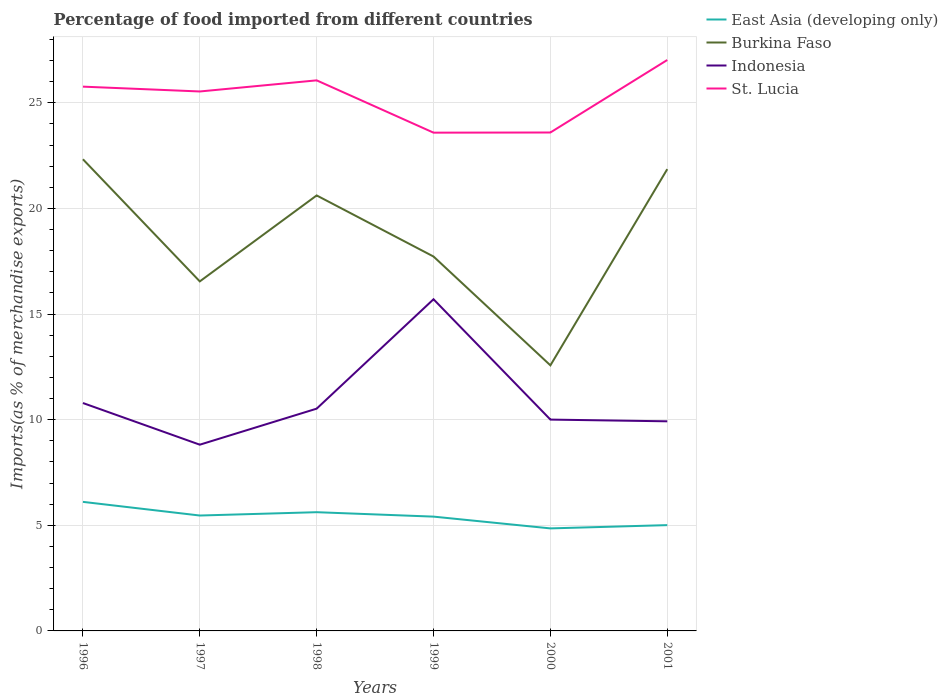Is the number of lines equal to the number of legend labels?
Offer a very short reply. Yes. Across all years, what is the maximum percentage of imports to different countries in Indonesia?
Your answer should be very brief. 8.82. What is the total percentage of imports to different countries in Indonesia in the graph?
Your response must be concise. -6.88. What is the difference between the highest and the second highest percentage of imports to different countries in St. Lucia?
Your answer should be compact. 3.44. What is the difference between the highest and the lowest percentage of imports to different countries in St. Lucia?
Ensure brevity in your answer.  4. How many lines are there?
Keep it short and to the point. 4. How many years are there in the graph?
Make the answer very short. 6. Does the graph contain any zero values?
Your answer should be compact. No. Does the graph contain grids?
Offer a very short reply. Yes. Where does the legend appear in the graph?
Give a very brief answer. Top right. How are the legend labels stacked?
Offer a very short reply. Vertical. What is the title of the graph?
Ensure brevity in your answer.  Percentage of food imported from different countries. What is the label or title of the X-axis?
Your response must be concise. Years. What is the label or title of the Y-axis?
Provide a succinct answer. Imports(as % of merchandise exports). What is the Imports(as % of merchandise exports) of East Asia (developing only) in 1996?
Offer a very short reply. 6.11. What is the Imports(as % of merchandise exports) in Burkina Faso in 1996?
Provide a short and direct response. 22.33. What is the Imports(as % of merchandise exports) of Indonesia in 1996?
Your response must be concise. 10.79. What is the Imports(as % of merchandise exports) of St. Lucia in 1996?
Ensure brevity in your answer.  25.77. What is the Imports(as % of merchandise exports) in East Asia (developing only) in 1997?
Give a very brief answer. 5.46. What is the Imports(as % of merchandise exports) of Burkina Faso in 1997?
Give a very brief answer. 16.55. What is the Imports(as % of merchandise exports) in Indonesia in 1997?
Make the answer very short. 8.82. What is the Imports(as % of merchandise exports) in St. Lucia in 1997?
Offer a very short reply. 25.54. What is the Imports(as % of merchandise exports) in East Asia (developing only) in 1998?
Make the answer very short. 5.62. What is the Imports(as % of merchandise exports) in Burkina Faso in 1998?
Give a very brief answer. 20.62. What is the Imports(as % of merchandise exports) in Indonesia in 1998?
Ensure brevity in your answer.  10.52. What is the Imports(as % of merchandise exports) of St. Lucia in 1998?
Provide a short and direct response. 26.06. What is the Imports(as % of merchandise exports) of East Asia (developing only) in 1999?
Offer a terse response. 5.41. What is the Imports(as % of merchandise exports) of Burkina Faso in 1999?
Offer a terse response. 17.72. What is the Imports(as % of merchandise exports) in Indonesia in 1999?
Ensure brevity in your answer.  15.7. What is the Imports(as % of merchandise exports) of St. Lucia in 1999?
Your response must be concise. 23.59. What is the Imports(as % of merchandise exports) in East Asia (developing only) in 2000?
Offer a terse response. 4.85. What is the Imports(as % of merchandise exports) of Burkina Faso in 2000?
Your response must be concise. 12.57. What is the Imports(as % of merchandise exports) in Indonesia in 2000?
Keep it short and to the point. 10. What is the Imports(as % of merchandise exports) in St. Lucia in 2000?
Your response must be concise. 23.6. What is the Imports(as % of merchandise exports) in East Asia (developing only) in 2001?
Make the answer very short. 5.01. What is the Imports(as % of merchandise exports) in Burkina Faso in 2001?
Your response must be concise. 21.86. What is the Imports(as % of merchandise exports) of Indonesia in 2001?
Offer a terse response. 9.92. What is the Imports(as % of merchandise exports) of St. Lucia in 2001?
Your response must be concise. 27.03. Across all years, what is the maximum Imports(as % of merchandise exports) in East Asia (developing only)?
Keep it short and to the point. 6.11. Across all years, what is the maximum Imports(as % of merchandise exports) in Burkina Faso?
Keep it short and to the point. 22.33. Across all years, what is the maximum Imports(as % of merchandise exports) of Indonesia?
Provide a short and direct response. 15.7. Across all years, what is the maximum Imports(as % of merchandise exports) in St. Lucia?
Ensure brevity in your answer.  27.03. Across all years, what is the minimum Imports(as % of merchandise exports) of East Asia (developing only)?
Offer a very short reply. 4.85. Across all years, what is the minimum Imports(as % of merchandise exports) in Burkina Faso?
Offer a terse response. 12.57. Across all years, what is the minimum Imports(as % of merchandise exports) in Indonesia?
Provide a short and direct response. 8.82. Across all years, what is the minimum Imports(as % of merchandise exports) of St. Lucia?
Make the answer very short. 23.59. What is the total Imports(as % of merchandise exports) of East Asia (developing only) in the graph?
Offer a very short reply. 32.47. What is the total Imports(as % of merchandise exports) of Burkina Faso in the graph?
Make the answer very short. 111.65. What is the total Imports(as % of merchandise exports) of Indonesia in the graph?
Your answer should be compact. 65.76. What is the total Imports(as % of merchandise exports) in St. Lucia in the graph?
Offer a terse response. 151.58. What is the difference between the Imports(as % of merchandise exports) in East Asia (developing only) in 1996 and that in 1997?
Your response must be concise. 0.65. What is the difference between the Imports(as % of merchandise exports) of Burkina Faso in 1996 and that in 1997?
Ensure brevity in your answer.  5.78. What is the difference between the Imports(as % of merchandise exports) in Indonesia in 1996 and that in 1997?
Ensure brevity in your answer.  1.97. What is the difference between the Imports(as % of merchandise exports) of St. Lucia in 1996 and that in 1997?
Make the answer very short. 0.23. What is the difference between the Imports(as % of merchandise exports) in East Asia (developing only) in 1996 and that in 1998?
Your response must be concise. 0.49. What is the difference between the Imports(as % of merchandise exports) of Burkina Faso in 1996 and that in 1998?
Your answer should be compact. 1.71. What is the difference between the Imports(as % of merchandise exports) in Indonesia in 1996 and that in 1998?
Provide a short and direct response. 0.27. What is the difference between the Imports(as % of merchandise exports) in St. Lucia in 1996 and that in 1998?
Keep it short and to the point. -0.3. What is the difference between the Imports(as % of merchandise exports) of East Asia (developing only) in 1996 and that in 1999?
Offer a very short reply. 0.7. What is the difference between the Imports(as % of merchandise exports) in Burkina Faso in 1996 and that in 1999?
Ensure brevity in your answer.  4.6. What is the difference between the Imports(as % of merchandise exports) of Indonesia in 1996 and that in 1999?
Make the answer very short. -4.91. What is the difference between the Imports(as % of merchandise exports) of St. Lucia in 1996 and that in 1999?
Your answer should be compact. 2.18. What is the difference between the Imports(as % of merchandise exports) of East Asia (developing only) in 1996 and that in 2000?
Provide a short and direct response. 1.26. What is the difference between the Imports(as % of merchandise exports) of Burkina Faso in 1996 and that in 2000?
Provide a short and direct response. 9.76. What is the difference between the Imports(as % of merchandise exports) of Indonesia in 1996 and that in 2000?
Give a very brief answer. 0.78. What is the difference between the Imports(as % of merchandise exports) of St. Lucia in 1996 and that in 2000?
Offer a very short reply. 2.17. What is the difference between the Imports(as % of merchandise exports) in East Asia (developing only) in 1996 and that in 2001?
Provide a succinct answer. 1.1. What is the difference between the Imports(as % of merchandise exports) of Burkina Faso in 1996 and that in 2001?
Provide a succinct answer. 0.47. What is the difference between the Imports(as % of merchandise exports) of Indonesia in 1996 and that in 2001?
Provide a short and direct response. 0.87. What is the difference between the Imports(as % of merchandise exports) in St. Lucia in 1996 and that in 2001?
Offer a terse response. -1.26. What is the difference between the Imports(as % of merchandise exports) of East Asia (developing only) in 1997 and that in 1998?
Offer a terse response. -0.16. What is the difference between the Imports(as % of merchandise exports) of Burkina Faso in 1997 and that in 1998?
Your response must be concise. -4.07. What is the difference between the Imports(as % of merchandise exports) of Indonesia in 1997 and that in 1998?
Offer a terse response. -1.71. What is the difference between the Imports(as % of merchandise exports) of St. Lucia in 1997 and that in 1998?
Your answer should be very brief. -0.53. What is the difference between the Imports(as % of merchandise exports) of East Asia (developing only) in 1997 and that in 1999?
Provide a short and direct response. 0.05. What is the difference between the Imports(as % of merchandise exports) in Burkina Faso in 1997 and that in 1999?
Offer a very short reply. -1.18. What is the difference between the Imports(as % of merchandise exports) in Indonesia in 1997 and that in 1999?
Offer a very short reply. -6.88. What is the difference between the Imports(as % of merchandise exports) in St. Lucia in 1997 and that in 1999?
Your answer should be compact. 1.95. What is the difference between the Imports(as % of merchandise exports) in East Asia (developing only) in 1997 and that in 2000?
Provide a short and direct response. 0.61. What is the difference between the Imports(as % of merchandise exports) in Burkina Faso in 1997 and that in 2000?
Give a very brief answer. 3.97. What is the difference between the Imports(as % of merchandise exports) of Indonesia in 1997 and that in 2000?
Make the answer very short. -1.19. What is the difference between the Imports(as % of merchandise exports) in St. Lucia in 1997 and that in 2000?
Your response must be concise. 1.94. What is the difference between the Imports(as % of merchandise exports) in East Asia (developing only) in 1997 and that in 2001?
Your response must be concise. 0.45. What is the difference between the Imports(as % of merchandise exports) of Burkina Faso in 1997 and that in 2001?
Provide a succinct answer. -5.31. What is the difference between the Imports(as % of merchandise exports) in Indonesia in 1997 and that in 2001?
Give a very brief answer. -1.11. What is the difference between the Imports(as % of merchandise exports) of St. Lucia in 1997 and that in 2001?
Keep it short and to the point. -1.49. What is the difference between the Imports(as % of merchandise exports) of East Asia (developing only) in 1998 and that in 1999?
Provide a succinct answer. 0.21. What is the difference between the Imports(as % of merchandise exports) in Burkina Faso in 1998 and that in 1999?
Make the answer very short. 2.89. What is the difference between the Imports(as % of merchandise exports) of Indonesia in 1998 and that in 1999?
Your answer should be compact. -5.18. What is the difference between the Imports(as % of merchandise exports) of St. Lucia in 1998 and that in 1999?
Your answer should be very brief. 2.48. What is the difference between the Imports(as % of merchandise exports) of East Asia (developing only) in 1998 and that in 2000?
Provide a succinct answer. 0.77. What is the difference between the Imports(as % of merchandise exports) in Burkina Faso in 1998 and that in 2000?
Your answer should be very brief. 8.04. What is the difference between the Imports(as % of merchandise exports) of Indonesia in 1998 and that in 2000?
Offer a terse response. 0.52. What is the difference between the Imports(as % of merchandise exports) of St. Lucia in 1998 and that in 2000?
Keep it short and to the point. 2.47. What is the difference between the Imports(as % of merchandise exports) in East Asia (developing only) in 1998 and that in 2001?
Provide a short and direct response. 0.61. What is the difference between the Imports(as % of merchandise exports) in Burkina Faso in 1998 and that in 2001?
Provide a short and direct response. -1.25. What is the difference between the Imports(as % of merchandise exports) of Indonesia in 1998 and that in 2001?
Offer a terse response. 0.6. What is the difference between the Imports(as % of merchandise exports) in St. Lucia in 1998 and that in 2001?
Provide a succinct answer. -0.96. What is the difference between the Imports(as % of merchandise exports) of East Asia (developing only) in 1999 and that in 2000?
Your answer should be compact. 0.56. What is the difference between the Imports(as % of merchandise exports) in Burkina Faso in 1999 and that in 2000?
Keep it short and to the point. 5.15. What is the difference between the Imports(as % of merchandise exports) in Indonesia in 1999 and that in 2000?
Provide a short and direct response. 5.7. What is the difference between the Imports(as % of merchandise exports) in St. Lucia in 1999 and that in 2000?
Provide a succinct answer. -0.01. What is the difference between the Imports(as % of merchandise exports) of East Asia (developing only) in 1999 and that in 2001?
Offer a very short reply. 0.4. What is the difference between the Imports(as % of merchandise exports) in Burkina Faso in 1999 and that in 2001?
Make the answer very short. -4.14. What is the difference between the Imports(as % of merchandise exports) of Indonesia in 1999 and that in 2001?
Keep it short and to the point. 5.78. What is the difference between the Imports(as % of merchandise exports) in St. Lucia in 1999 and that in 2001?
Offer a terse response. -3.44. What is the difference between the Imports(as % of merchandise exports) of East Asia (developing only) in 2000 and that in 2001?
Provide a succinct answer. -0.15. What is the difference between the Imports(as % of merchandise exports) of Burkina Faso in 2000 and that in 2001?
Your response must be concise. -9.29. What is the difference between the Imports(as % of merchandise exports) in Indonesia in 2000 and that in 2001?
Your response must be concise. 0.08. What is the difference between the Imports(as % of merchandise exports) of St. Lucia in 2000 and that in 2001?
Your answer should be very brief. -3.43. What is the difference between the Imports(as % of merchandise exports) of East Asia (developing only) in 1996 and the Imports(as % of merchandise exports) of Burkina Faso in 1997?
Provide a short and direct response. -10.44. What is the difference between the Imports(as % of merchandise exports) of East Asia (developing only) in 1996 and the Imports(as % of merchandise exports) of Indonesia in 1997?
Provide a succinct answer. -2.71. What is the difference between the Imports(as % of merchandise exports) in East Asia (developing only) in 1996 and the Imports(as % of merchandise exports) in St. Lucia in 1997?
Provide a succinct answer. -19.43. What is the difference between the Imports(as % of merchandise exports) in Burkina Faso in 1996 and the Imports(as % of merchandise exports) in Indonesia in 1997?
Give a very brief answer. 13.51. What is the difference between the Imports(as % of merchandise exports) in Burkina Faso in 1996 and the Imports(as % of merchandise exports) in St. Lucia in 1997?
Offer a very short reply. -3.21. What is the difference between the Imports(as % of merchandise exports) in Indonesia in 1996 and the Imports(as % of merchandise exports) in St. Lucia in 1997?
Your answer should be very brief. -14.75. What is the difference between the Imports(as % of merchandise exports) of East Asia (developing only) in 1996 and the Imports(as % of merchandise exports) of Burkina Faso in 1998?
Your response must be concise. -14.51. What is the difference between the Imports(as % of merchandise exports) in East Asia (developing only) in 1996 and the Imports(as % of merchandise exports) in Indonesia in 1998?
Your answer should be very brief. -4.41. What is the difference between the Imports(as % of merchandise exports) of East Asia (developing only) in 1996 and the Imports(as % of merchandise exports) of St. Lucia in 1998?
Keep it short and to the point. -19.95. What is the difference between the Imports(as % of merchandise exports) in Burkina Faso in 1996 and the Imports(as % of merchandise exports) in Indonesia in 1998?
Your response must be concise. 11.81. What is the difference between the Imports(as % of merchandise exports) of Burkina Faso in 1996 and the Imports(as % of merchandise exports) of St. Lucia in 1998?
Give a very brief answer. -3.74. What is the difference between the Imports(as % of merchandise exports) in Indonesia in 1996 and the Imports(as % of merchandise exports) in St. Lucia in 1998?
Ensure brevity in your answer.  -15.28. What is the difference between the Imports(as % of merchandise exports) of East Asia (developing only) in 1996 and the Imports(as % of merchandise exports) of Burkina Faso in 1999?
Make the answer very short. -11.61. What is the difference between the Imports(as % of merchandise exports) in East Asia (developing only) in 1996 and the Imports(as % of merchandise exports) in Indonesia in 1999?
Offer a terse response. -9.59. What is the difference between the Imports(as % of merchandise exports) of East Asia (developing only) in 1996 and the Imports(as % of merchandise exports) of St. Lucia in 1999?
Your answer should be compact. -17.48. What is the difference between the Imports(as % of merchandise exports) in Burkina Faso in 1996 and the Imports(as % of merchandise exports) in Indonesia in 1999?
Your response must be concise. 6.63. What is the difference between the Imports(as % of merchandise exports) of Burkina Faso in 1996 and the Imports(as % of merchandise exports) of St. Lucia in 1999?
Your response must be concise. -1.26. What is the difference between the Imports(as % of merchandise exports) of Indonesia in 1996 and the Imports(as % of merchandise exports) of St. Lucia in 1999?
Make the answer very short. -12.8. What is the difference between the Imports(as % of merchandise exports) in East Asia (developing only) in 1996 and the Imports(as % of merchandise exports) in Burkina Faso in 2000?
Offer a terse response. -6.46. What is the difference between the Imports(as % of merchandise exports) of East Asia (developing only) in 1996 and the Imports(as % of merchandise exports) of Indonesia in 2000?
Offer a terse response. -3.9. What is the difference between the Imports(as % of merchandise exports) of East Asia (developing only) in 1996 and the Imports(as % of merchandise exports) of St. Lucia in 2000?
Your answer should be compact. -17.49. What is the difference between the Imports(as % of merchandise exports) of Burkina Faso in 1996 and the Imports(as % of merchandise exports) of Indonesia in 2000?
Provide a short and direct response. 12.32. What is the difference between the Imports(as % of merchandise exports) of Burkina Faso in 1996 and the Imports(as % of merchandise exports) of St. Lucia in 2000?
Offer a terse response. -1.27. What is the difference between the Imports(as % of merchandise exports) in Indonesia in 1996 and the Imports(as % of merchandise exports) in St. Lucia in 2000?
Ensure brevity in your answer.  -12.81. What is the difference between the Imports(as % of merchandise exports) in East Asia (developing only) in 1996 and the Imports(as % of merchandise exports) in Burkina Faso in 2001?
Provide a succinct answer. -15.75. What is the difference between the Imports(as % of merchandise exports) in East Asia (developing only) in 1996 and the Imports(as % of merchandise exports) in Indonesia in 2001?
Provide a succinct answer. -3.81. What is the difference between the Imports(as % of merchandise exports) in East Asia (developing only) in 1996 and the Imports(as % of merchandise exports) in St. Lucia in 2001?
Keep it short and to the point. -20.92. What is the difference between the Imports(as % of merchandise exports) of Burkina Faso in 1996 and the Imports(as % of merchandise exports) of Indonesia in 2001?
Your answer should be compact. 12.41. What is the difference between the Imports(as % of merchandise exports) of Burkina Faso in 1996 and the Imports(as % of merchandise exports) of St. Lucia in 2001?
Your response must be concise. -4.7. What is the difference between the Imports(as % of merchandise exports) in Indonesia in 1996 and the Imports(as % of merchandise exports) in St. Lucia in 2001?
Ensure brevity in your answer.  -16.24. What is the difference between the Imports(as % of merchandise exports) of East Asia (developing only) in 1997 and the Imports(as % of merchandise exports) of Burkina Faso in 1998?
Your answer should be compact. -15.15. What is the difference between the Imports(as % of merchandise exports) of East Asia (developing only) in 1997 and the Imports(as % of merchandise exports) of Indonesia in 1998?
Your answer should be compact. -5.06. What is the difference between the Imports(as % of merchandise exports) in East Asia (developing only) in 1997 and the Imports(as % of merchandise exports) in St. Lucia in 1998?
Keep it short and to the point. -20.6. What is the difference between the Imports(as % of merchandise exports) in Burkina Faso in 1997 and the Imports(as % of merchandise exports) in Indonesia in 1998?
Provide a short and direct response. 6.02. What is the difference between the Imports(as % of merchandise exports) in Burkina Faso in 1997 and the Imports(as % of merchandise exports) in St. Lucia in 1998?
Offer a very short reply. -9.52. What is the difference between the Imports(as % of merchandise exports) of Indonesia in 1997 and the Imports(as % of merchandise exports) of St. Lucia in 1998?
Your answer should be very brief. -17.25. What is the difference between the Imports(as % of merchandise exports) of East Asia (developing only) in 1997 and the Imports(as % of merchandise exports) of Burkina Faso in 1999?
Ensure brevity in your answer.  -12.26. What is the difference between the Imports(as % of merchandise exports) of East Asia (developing only) in 1997 and the Imports(as % of merchandise exports) of Indonesia in 1999?
Offer a very short reply. -10.24. What is the difference between the Imports(as % of merchandise exports) of East Asia (developing only) in 1997 and the Imports(as % of merchandise exports) of St. Lucia in 1999?
Make the answer very short. -18.13. What is the difference between the Imports(as % of merchandise exports) in Burkina Faso in 1997 and the Imports(as % of merchandise exports) in Indonesia in 1999?
Provide a short and direct response. 0.85. What is the difference between the Imports(as % of merchandise exports) in Burkina Faso in 1997 and the Imports(as % of merchandise exports) in St. Lucia in 1999?
Offer a very short reply. -7.04. What is the difference between the Imports(as % of merchandise exports) in Indonesia in 1997 and the Imports(as % of merchandise exports) in St. Lucia in 1999?
Provide a short and direct response. -14.77. What is the difference between the Imports(as % of merchandise exports) in East Asia (developing only) in 1997 and the Imports(as % of merchandise exports) in Burkina Faso in 2000?
Ensure brevity in your answer.  -7.11. What is the difference between the Imports(as % of merchandise exports) in East Asia (developing only) in 1997 and the Imports(as % of merchandise exports) in Indonesia in 2000?
Offer a terse response. -4.54. What is the difference between the Imports(as % of merchandise exports) of East Asia (developing only) in 1997 and the Imports(as % of merchandise exports) of St. Lucia in 2000?
Make the answer very short. -18.13. What is the difference between the Imports(as % of merchandise exports) of Burkina Faso in 1997 and the Imports(as % of merchandise exports) of Indonesia in 2000?
Offer a terse response. 6.54. What is the difference between the Imports(as % of merchandise exports) of Burkina Faso in 1997 and the Imports(as % of merchandise exports) of St. Lucia in 2000?
Your answer should be very brief. -7.05. What is the difference between the Imports(as % of merchandise exports) of Indonesia in 1997 and the Imports(as % of merchandise exports) of St. Lucia in 2000?
Your response must be concise. -14.78. What is the difference between the Imports(as % of merchandise exports) in East Asia (developing only) in 1997 and the Imports(as % of merchandise exports) in Burkina Faso in 2001?
Offer a terse response. -16.4. What is the difference between the Imports(as % of merchandise exports) of East Asia (developing only) in 1997 and the Imports(as % of merchandise exports) of Indonesia in 2001?
Ensure brevity in your answer.  -4.46. What is the difference between the Imports(as % of merchandise exports) of East Asia (developing only) in 1997 and the Imports(as % of merchandise exports) of St. Lucia in 2001?
Provide a short and direct response. -21.57. What is the difference between the Imports(as % of merchandise exports) in Burkina Faso in 1997 and the Imports(as % of merchandise exports) in Indonesia in 2001?
Your response must be concise. 6.62. What is the difference between the Imports(as % of merchandise exports) in Burkina Faso in 1997 and the Imports(as % of merchandise exports) in St. Lucia in 2001?
Offer a very short reply. -10.48. What is the difference between the Imports(as % of merchandise exports) in Indonesia in 1997 and the Imports(as % of merchandise exports) in St. Lucia in 2001?
Make the answer very short. -18.21. What is the difference between the Imports(as % of merchandise exports) in East Asia (developing only) in 1998 and the Imports(as % of merchandise exports) in Burkina Faso in 1999?
Your answer should be very brief. -12.1. What is the difference between the Imports(as % of merchandise exports) of East Asia (developing only) in 1998 and the Imports(as % of merchandise exports) of Indonesia in 1999?
Provide a short and direct response. -10.08. What is the difference between the Imports(as % of merchandise exports) of East Asia (developing only) in 1998 and the Imports(as % of merchandise exports) of St. Lucia in 1999?
Your response must be concise. -17.97. What is the difference between the Imports(as % of merchandise exports) in Burkina Faso in 1998 and the Imports(as % of merchandise exports) in Indonesia in 1999?
Keep it short and to the point. 4.91. What is the difference between the Imports(as % of merchandise exports) in Burkina Faso in 1998 and the Imports(as % of merchandise exports) in St. Lucia in 1999?
Offer a very short reply. -2.97. What is the difference between the Imports(as % of merchandise exports) in Indonesia in 1998 and the Imports(as % of merchandise exports) in St. Lucia in 1999?
Your answer should be compact. -13.07. What is the difference between the Imports(as % of merchandise exports) in East Asia (developing only) in 1998 and the Imports(as % of merchandise exports) in Burkina Faso in 2000?
Keep it short and to the point. -6.95. What is the difference between the Imports(as % of merchandise exports) of East Asia (developing only) in 1998 and the Imports(as % of merchandise exports) of Indonesia in 2000?
Your answer should be very brief. -4.38. What is the difference between the Imports(as % of merchandise exports) of East Asia (developing only) in 1998 and the Imports(as % of merchandise exports) of St. Lucia in 2000?
Keep it short and to the point. -17.98. What is the difference between the Imports(as % of merchandise exports) in Burkina Faso in 1998 and the Imports(as % of merchandise exports) in Indonesia in 2000?
Give a very brief answer. 10.61. What is the difference between the Imports(as % of merchandise exports) in Burkina Faso in 1998 and the Imports(as % of merchandise exports) in St. Lucia in 2000?
Ensure brevity in your answer.  -2.98. What is the difference between the Imports(as % of merchandise exports) of Indonesia in 1998 and the Imports(as % of merchandise exports) of St. Lucia in 2000?
Keep it short and to the point. -13.07. What is the difference between the Imports(as % of merchandise exports) of East Asia (developing only) in 1998 and the Imports(as % of merchandise exports) of Burkina Faso in 2001?
Your answer should be compact. -16.24. What is the difference between the Imports(as % of merchandise exports) in East Asia (developing only) in 1998 and the Imports(as % of merchandise exports) in Indonesia in 2001?
Your answer should be very brief. -4.3. What is the difference between the Imports(as % of merchandise exports) in East Asia (developing only) in 1998 and the Imports(as % of merchandise exports) in St. Lucia in 2001?
Offer a very short reply. -21.41. What is the difference between the Imports(as % of merchandise exports) of Burkina Faso in 1998 and the Imports(as % of merchandise exports) of Indonesia in 2001?
Your answer should be very brief. 10.69. What is the difference between the Imports(as % of merchandise exports) of Burkina Faso in 1998 and the Imports(as % of merchandise exports) of St. Lucia in 2001?
Provide a succinct answer. -6.41. What is the difference between the Imports(as % of merchandise exports) in Indonesia in 1998 and the Imports(as % of merchandise exports) in St. Lucia in 2001?
Give a very brief answer. -16.51. What is the difference between the Imports(as % of merchandise exports) of East Asia (developing only) in 1999 and the Imports(as % of merchandise exports) of Burkina Faso in 2000?
Your answer should be compact. -7.16. What is the difference between the Imports(as % of merchandise exports) of East Asia (developing only) in 1999 and the Imports(as % of merchandise exports) of Indonesia in 2000?
Ensure brevity in your answer.  -4.59. What is the difference between the Imports(as % of merchandise exports) in East Asia (developing only) in 1999 and the Imports(as % of merchandise exports) in St. Lucia in 2000?
Give a very brief answer. -18.18. What is the difference between the Imports(as % of merchandise exports) in Burkina Faso in 1999 and the Imports(as % of merchandise exports) in Indonesia in 2000?
Your answer should be compact. 7.72. What is the difference between the Imports(as % of merchandise exports) of Burkina Faso in 1999 and the Imports(as % of merchandise exports) of St. Lucia in 2000?
Give a very brief answer. -5.87. What is the difference between the Imports(as % of merchandise exports) of Indonesia in 1999 and the Imports(as % of merchandise exports) of St. Lucia in 2000?
Ensure brevity in your answer.  -7.89. What is the difference between the Imports(as % of merchandise exports) in East Asia (developing only) in 1999 and the Imports(as % of merchandise exports) in Burkina Faso in 2001?
Your response must be concise. -16.45. What is the difference between the Imports(as % of merchandise exports) of East Asia (developing only) in 1999 and the Imports(as % of merchandise exports) of Indonesia in 2001?
Offer a terse response. -4.51. What is the difference between the Imports(as % of merchandise exports) in East Asia (developing only) in 1999 and the Imports(as % of merchandise exports) in St. Lucia in 2001?
Provide a succinct answer. -21.62. What is the difference between the Imports(as % of merchandise exports) in Burkina Faso in 1999 and the Imports(as % of merchandise exports) in Indonesia in 2001?
Ensure brevity in your answer.  7.8. What is the difference between the Imports(as % of merchandise exports) in Burkina Faso in 1999 and the Imports(as % of merchandise exports) in St. Lucia in 2001?
Provide a succinct answer. -9.3. What is the difference between the Imports(as % of merchandise exports) of Indonesia in 1999 and the Imports(as % of merchandise exports) of St. Lucia in 2001?
Offer a terse response. -11.33. What is the difference between the Imports(as % of merchandise exports) of East Asia (developing only) in 2000 and the Imports(as % of merchandise exports) of Burkina Faso in 2001?
Your answer should be very brief. -17.01. What is the difference between the Imports(as % of merchandise exports) of East Asia (developing only) in 2000 and the Imports(as % of merchandise exports) of Indonesia in 2001?
Your answer should be very brief. -5.07. What is the difference between the Imports(as % of merchandise exports) in East Asia (developing only) in 2000 and the Imports(as % of merchandise exports) in St. Lucia in 2001?
Your response must be concise. -22.17. What is the difference between the Imports(as % of merchandise exports) of Burkina Faso in 2000 and the Imports(as % of merchandise exports) of Indonesia in 2001?
Offer a very short reply. 2.65. What is the difference between the Imports(as % of merchandise exports) of Burkina Faso in 2000 and the Imports(as % of merchandise exports) of St. Lucia in 2001?
Provide a succinct answer. -14.46. What is the difference between the Imports(as % of merchandise exports) of Indonesia in 2000 and the Imports(as % of merchandise exports) of St. Lucia in 2001?
Your response must be concise. -17.02. What is the average Imports(as % of merchandise exports) of East Asia (developing only) per year?
Your answer should be very brief. 5.41. What is the average Imports(as % of merchandise exports) of Burkina Faso per year?
Make the answer very short. 18.61. What is the average Imports(as % of merchandise exports) in Indonesia per year?
Ensure brevity in your answer.  10.96. What is the average Imports(as % of merchandise exports) in St. Lucia per year?
Ensure brevity in your answer.  25.26. In the year 1996, what is the difference between the Imports(as % of merchandise exports) in East Asia (developing only) and Imports(as % of merchandise exports) in Burkina Faso?
Provide a short and direct response. -16.22. In the year 1996, what is the difference between the Imports(as % of merchandise exports) of East Asia (developing only) and Imports(as % of merchandise exports) of Indonesia?
Ensure brevity in your answer.  -4.68. In the year 1996, what is the difference between the Imports(as % of merchandise exports) in East Asia (developing only) and Imports(as % of merchandise exports) in St. Lucia?
Give a very brief answer. -19.66. In the year 1996, what is the difference between the Imports(as % of merchandise exports) in Burkina Faso and Imports(as % of merchandise exports) in Indonesia?
Your response must be concise. 11.54. In the year 1996, what is the difference between the Imports(as % of merchandise exports) in Burkina Faso and Imports(as % of merchandise exports) in St. Lucia?
Provide a succinct answer. -3.44. In the year 1996, what is the difference between the Imports(as % of merchandise exports) in Indonesia and Imports(as % of merchandise exports) in St. Lucia?
Offer a terse response. -14.98. In the year 1997, what is the difference between the Imports(as % of merchandise exports) of East Asia (developing only) and Imports(as % of merchandise exports) of Burkina Faso?
Offer a very short reply. -11.08. In the year 1997, what is the difference between the Imports(as % of merchandise exports) of East Asia (developing only) and Imports(as % of merchandise exports) of Indonesia?
Your response must be concise. -3.35. In the year 1997, what is the difference between the Imports(as % of merchandise exports) of East Asia (developing only) and Imports(as % of merchandise exports) of St. Lucia?
Your answer should be compact. -20.07. In the year 1997, what is the difference between the Imports(as % of merchandise exports) of Burkina Faso and Imports(as % of merchandise exports) of Indonesia?
Provide a succinct answer. 7.73. In the year 1997, what is the difference between the Imports(as % of merchandise exports) in Burkina Faso and Imports(as % of merchandise exports) in St. Lucia?
Provide a succinct answer. -8.99. In the year 1997, what is the difference between the Imports(as % of merchandise exports) of Indonesia and Imports(as % of merchandise exports) of St. Lucia?
Offer a terse response. -16.72. In the year 1998, what is the difference between the Imports(as % of merchandise exports) in East Asia (developing only) and Imports(as % of merchandise exports) in Burkina Faso?
Give a very brief answer. -15. In the year 1998, what is the difference between the Imports(as % of merchandise exports) of East Asia (developing only) and Imports(as % of merchandise exports) of Indonesia?
Give a very brief answer. -4.9. In the year 1998, what is the difference between the Imports(as % of merchandise exports) of East Asia (developing only) and Imports(as % of merchandise exports) of St. Lucia?
Your answer should be compact. -20.44. In the year 1998, what is the difference between the Imports(as % of merchandise exports) of Burkina Faso and Imports(as % of merchandise exports) of Indonesia?
Give a very brief answer. 10.09. In the year 1998, what is the difference between the Imports(as % of merchandise exports) of Burkina Faso and Imports(as % of merchandise exports) of St. Lucia?
Provide a succinct answer. -5.45. In the year 1998, what is the difference between the Imports(as % of merchandise exports) in Indonesia and Imports(as % of merchandise exports) in St. Lucia?
Offer a terse response. -15.54. In the year 1999, what is the difference between the Imports(as % of merchandise exports) in East Asia (developing only) and Imports(as % of merchandise exports) in Burkina Faso?
Provide a succinct answer. -12.31. In the year 1999, what is the difference between the Imports(as % of merchandise exports) of East Asia (developing only) and Imports(as % of merchandise exports) of Indonesia?
Offer a terse response. -10.29. In the year 1999, what is the difference between the Imports(as % of merchandise exports) in East Asia (developing only) and Imports(as % of merchandise exports) in St. Lucia?
Offer a terse response. -18.18. In the year 1999, what is the difference between the Imports(as % of merchandise exports) of Burkina Faso and Imports(as % of merchandise exports) of Indonesia?
Give a very brief answer. 2.02. In the year 1999, what is the difference between the Imports(as % of merchandise exports) of Burkina Faso and Imports(as % of merchandise exports) of St. Lucia?
Your response must be concise. -5.86. In the year 1999, what is the difference between the Imports(as % of merchandise exports) in Indonesia and Imports(as % of merchandise exports) in St. Lucia?
Your response must be concise. -7.89. In the year 2000, what is the difference between the Imports(as % of merchandise exports) of East Asia (developing only) and Imports(as % of merchandise exports) of Burkina Faso?
Make the answer very short. -7.72. In the year 2000, what is the difference between the Imports(as % of merchandise exports) of East Asia (developing only) and Imports(as % of merchandise exports) of Indonesia?
Offer a very short reply. -5.15. In the year 2000, what is the difference between the Imports(as % of merchandise exports) in East Asia (developing only) and Imports(as % of merchandise exports) in St. Lucia?
Keep it short and to the point. -18.74. In the year 2000, what is the difference between the Imports(as % of merchandise exports) in Burkina Faso and Imports(as % of merchandise exports) in Indonesia?
Provide a short and direct response. 2.57. In the year 2000, what is the difference between the Imports(as % of merchandise exports) of Burkina Faso and Imports(as % of merchandise exports) of St. Lucia?
Your response must be concise. -11.02. In the year 2000, what is the difference between the Imports(as % of merchandise exports) in Indonesia and Imports(as % of merchandise exports) in St. Lucia?
Your answer should be compact. -13.59. In the year 2001, what is the difference between the Imports(as % of merchandise exports) in East Asia (developing only) and Imports(as % of merchandise exports) in Burkina Faso?
Your response must be concise. -16.85. In the year 2001, what is the difference between the Imports(as % of merchandise exports) of East Asia (developing only) and Imports(as % of merchandise exports) of Indonesia?
Make the answer very short. -4.91. In the year 2001, what is the difference between the Imports(as % of merchandise exports) in East Asia (developing only) and Imports(as % of merchandise exports) in St. Lucia?
Keep it short and to the point. -22.02. In the year 2001, what is the difference between the Imports(as % of merchandise exports) of Burkina Faso and Imports(as % of merchandise exports) of Indonesia?
Offer a very short reply. 11.94. In the year 2001, what is the difference between the Imports(as % of merchandise exports) in Burkina Faso and Imports(as % of merchandise exports) in St. Lucia?
Your response must be concise. -5.17. In the year 2001, what is the difference between the Imports(as % of merchandise exports) of Indonesia and Imports(as % of merchandise exports) of St. Lucia?
Your response must be concise. -17.1. What is the ratio of the Imports(as % of merchandise exports) in East Asia (developing only) in 1996 to that in 1997?
Give a very brief answer. 1.12. What is the ratio of the Imports(as % of merchandise exports) in Burkina Faso in 1996 to that in 1997?
Offer a terse response. 1.35. What is the ratio of the Imports(as % of merchandise exports) in Indonesia in 1996 to that in 1997?
Your answer should be very brief. 1.22. What is the ratio of the Imports(as % of merchandise exports) in St. Lucia in 1996 to that in 1997?
Keep it short and to the point. 1.01. What is the ratio of the Imports(as % of merchandise exports) of East Asia (developing only) in 1996 to that in 1998?
Make the answer very short. 1.09. What is the ratio of the Imports(as % of merchandise exports) in Burkina Faso in 1996 to that in 1998?
Give a very brief answer. 1.08. What is the ratio of the Imports(as % of merchandise exports) in Indonesia in 1996 to that in 1998?
Your answer should be compact. 1.03. What is the ratio of the Imports(as % of merchandise exports) in St. Lucia in 1996 to that in 1998?
Provide a succinct answer. 0.99. What is the ratio of the Imports(as % of merchandise exports) of East Asia (developing only) in 1996 to that in 1999?
Offer a terse response. 1.13. What is the ratio of the Imports(as % of merchandise exports) of Burkina Faso in 1996 to that in 1999?
Offer a very short reply. 1.26. What is the ratio of the Imports(as % of merchandise exports) in Indonesia in 1996 to that in 1999?
Your answer should be compact. 0.69. What is the ratio of the Imports(as % of merchandise exports) in St. Lucia in 1996 to that in 1999?
Your response must be concise. 1.09. What is the ratio of the Imports(as % of merchandise exports) in East Asia (developing only) in 1996 to that in 2000?
Provide a succinct answer. 1.26. What is the ratio of the Imports(as % of merchandise exports) in Burkina Faso in 1996 to that in 2000?
Provide a succinct answer. 1.78. What is the ratio of the Imports(as % of merchandise exports) in Indonesia in 1996 to that in 2000?
Your response must be concise. 1.08. What is the ratio of the Imports(as % of merchandise exports) in St. Lucia in 1996 to that in 2000?
Offer a terse response. 1.09. What is the ratio of the Imports(as % of merchandise exports) in East Asia (developing only) in 1996 to that in 2001?
Make the answer very short. 1.22. What is the ratio of the Imports(as % of merchandise exports) of Burkina Faso in 1996 to that in 2001?
Ensure brevity in your answer.  1.02. What is the ratio of the Imports(as % of merchandise exports) of Indonesia in 1996 to that in 2001?
Ensure brevity in your answer.  1.09. What is the ratio of the Imports(as % of merchandise exports) in St. Lucia in 1996 to that in 2001?
Make the answer very short. 0.95. What is the ratio of the Imports(as % of merchandise exports) in East Asia (developing only) in 1997 to that in 1998?
Ensure brevity in your answer.  0.97. What is the ratio of the Imports(as % of merchandise exports) of Burkina Faso in 1997 to that in 1998?
Ensure brevity in your answer.  0.8. What is the ratio of the Imports(as % of merchandise exports) of Indonesia in 1997 to that in 1998?
Keep it short and to the point. 0.84. What is the ratio of the Imports(as % of merchandise exports) in St. Lucia in 1997 to that in 1998?
Provide a succinct answer. 0.98. What is the ratio of the Imports(as % of merchandise exports) of East Asia (developing only) in 1997 to that in 1999?
Give a very brief answer. 1.01. What is the ratio of the Imports(as % of merchandise exports) of Burkina Faso in 1997 to that in 1999?
Offer a terse response. 0.93. What is the ratio of the Imports(as % of merchandise exports) of Indonesia in 1997 to that in 1999?
Give a very brief answer. 0.56. What is the ratio of the Imports(as % of merchandise exports) in St. Lucia in 1997 to that in 1999?
Offer a very short reply. 1.08. What is the ratio of the Imports(as % of merchandise exports) in East Asia (developing only) in 1997 to that in 2000?
Your response must be concise. 1.13. What is the ratio of the Imports(as % of merchandise exports) of Burkina Faso in 1997 to that in 2000?
Offer a terse response. 1.32. What is the ratio of the Imports(as % of merchandise exports) in Indonesia in 1997 to that in 2000?
Keep it short and to the point. 0.88. What is the ratio of the Imports(as % of merchandise exports) in St. Lucia in 1997 to that in 2000?
Keep it short and to the point. 1.08. What is the ratio of the Imports(as % of merchandise exports) of East Asia (developing only) in 1997 to that in 2001?
Your answer should be compact. 1.09. What is the ratio of the Imports(as % of merchandise exports) of Burkina Faso in 1997 to that in 2001?
Offer a terse response. 0.76. What is the ratio of the Imports(as % of merchandise exports) in Indonesia in 1997 to that in 2001?
Provide a succinct answer. 0.89. What is the ratio of the Imports(as % of merchandise exports) of St. Lucia in 1997 to that in 2001?
Keep it short and to the point. 0.94. What is the ratio of the Imports(as % of merchandise exports) in East Asia (developing only) in 1998 to that in 1999?
Keep it short and to the point. 1.04. What is the ratio of the Imports(as % of merchandise exports) in Burkina Faso in 1998 to that in 1999?
Your answer should be very brief. 1.16. What is the ratio of the Imports(as % of merchandise exports) of Indonesia in 1998 to that in 1999?
Make the answer very short. 0.67. What is the ratio of the Imports(as % of merchandise exports) of St. Lucia in 1998 to that in 1999?
Your answer should be very brief. 1.1. What is the ratio of the Imports(as % of merchandise exports) of East Asia (developing only) in 1998 to that in 2000?
Your answer should be very brief. 1.16. What is the ratio of the Imports(as % of merchandise exports) in Burkina Faso in 1998 to that in 2000?
Offer a terse response. 1.64. What is the ratio of the Imports(as % of merchandise exports) of Indonesia in 1998 to that in 2000?
Keep it short and to the point. 1.05. What is the ratio of the Imports(as % of merchandise exports) in St. Lucia in 1998 to that in 2000?
Ensure brevity in your answer.  1.1. What is the ratio of the Imports(as % of merchandise exports) of East Asia (developing only) in 1998 to that in 2001?
Ensure brevity in your answer.  1.12. What is the ratio of the Imports(as % of merchandise exports) in Burkina Faso in 1998 to that in 2001?
Offer a terse response. 0.94. What is the ratio of the Imports(as % of merchandise exports) in Indonesia in 1998 to that in 2001?
Your answer should be compact. 1.06. What is the ratio of the Imports(as % of merchandise exports) in East Asia (developing only) in 1999 to that in 2000?
Make the answer very short. 1.11. What is the ratio of the Imports(as % of merchandise exports) in Burkina Faso in 1999 to that in 2000?
Give a very brief answer. 1.41. What is the ratio of the Imports(as % of merchandise exports) in Indonesia in 1999 to that in 2000?
Your answer should be compact. 1.57. What is the ratio of the Imports(as % of merchandise exports) in St. Lucia in 1999 to that in 2000?
Make the answer very short. 1. What is the ratio of the Imports(as % of merchandise exports) in East Asia (developing only) in 1999 to that in 2001?
Ensure brevity in your answer.  1.08. What is the ratio of the Imports(as % of merchandise exports) in Burkina Faso in 1999 to that in 2001?
Your answer should be very brief. 0.81. What is the ratio of the Imports(as % of merchandise exports) of Indonesia in 1999 to that in 2001?
Offer a terse response. 1.58. What is the ratio of the Imports(as % of merchandise exports) in St. Lucia in 1999 to that in 2001?
Provide a short and direct response. 0.87. What is the ratio of the Imports(as % of merchandise exports) in East Asia (developing only) in 2000 to that in 2001?
Offer a very short reply. 0.97. What is the ratio of the Imports(as % of merchandise exports) of Burkina Faso in 2000 to that in 2001?
Make the answer very short. 0.58. What is the ratio of the Imports(as % of merchandise exports) of Indonesia in 2000 to that in 2001?
Offer a terse response. 1.01. What is the ratio of the Imports(as % of merchandise exports) in St. Lucia in 2000 to that in 2001?
Your answer should be very brief. 0.87. What is the difference between the highest and the second highest Imports(as % of merchandise exports) in East Asia (developing only)?
Ensure brevity in your answer.  0.49. What is the difference between the highest and the second highest Imports(as % of merchandise exports) in Burkina Faso?
Your answer should be very brief. 0.47. What is the difference between the highest and the second highest Imports(as % of merchandise exports) in Indonesia?
Give a very brief answer. 4.91. What is the difference between the highest and the second highest Imports(as % of merchandise exports) of St. Lucia?
Your answer should be compact. 0.96. What is the difference between the highest and the lowest Imports(as % of merchandise exports) of East Asia (developing only)?
Ensure brevity in your answer.  1.26. What is the difference between the highest and the lowest Imports(as % of merchandise exports) of Burkina Faso?
Your answer should be very brief. 9.76. What is the difference between the highest and the lowest Imports(as % of merchandise exports) in Indonesia?
Give a very brief answer. 6.88. What is the difference between the highest and the lowest Imports(as % of merchandise exports) of St. Lucia?
Provide a succinct answer. 3.44. 